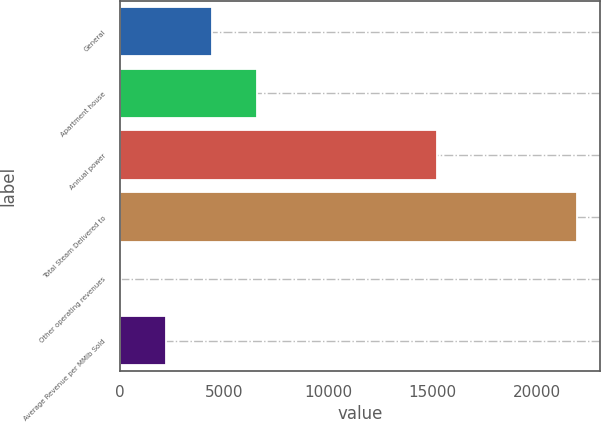Convert chart to OTSL. <chart><loc_0><loc_0><loc_500><loc_500><bar_chart><fcel>General<fcel>Apartment house<fcel>Annual power<fcel>Total Steam Delivered to<fcel>Other operating revenues<fcel>Average Revenue per MMlb Sold<nl><fcel>4405.4<fcel>6595.1<fcel>15195<fcel>21923<fcel>26<fcel>2215.7<nl></chart> 